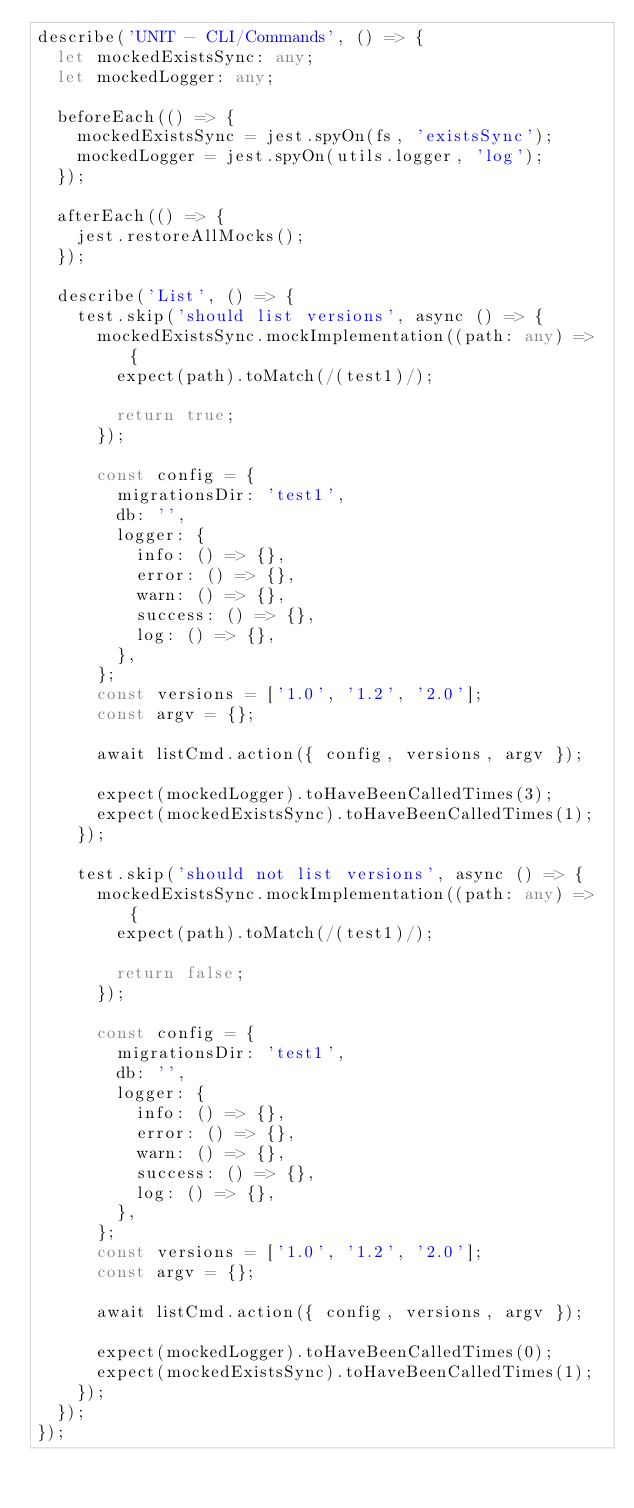<code> <loc_0><loc_0><loc_500><loc_500><_TypeScript_>describe('UNIT - CLI/Commands', () => {
  let mockedExistsSync: any;
  let mockedLogger: any;

  beforeEach(() => {
    mockedExistsSync = jest.spyOn(fs, 'existsSync');
    mockedLogger = jest.spyOn(utils.logger, 'log');
  });

  afterEach(() => {
    jest.restoreAllMocks();
  });

  describe('List', () => {
    test.skip('should list versions', async () => {
      mockedExistsSync.mockImplementation((path: any) => {
        expect(path).toMatch(/(test1)/);

        return true;
      });

      const config = {
        migrationsDir: 'test1',
        db: '',
        logger: {
          info: () => {},
          error: () => {},
          warn: () => {},
          success: () => {},
          log: () => {},
        },
      };
      const versions = ['1.0', '1.2', '2.0'];
      const argv = {};

      await listCmd.action({ config, versions, argv });

      expect(mockedLogger).toHaveBeenCalledTimes(3);
      expect(mockedExistsSync).toHaveBeenCalledTimes(1);
    });

    test.skip('should not list versions', async () => {
      mockedExistsSync.mockImplementation((path: any) => {
        expect(path).toMatch(/(test1)/);

        return false;
      });

      const config = {
        migrationsDir: 'test1',
        db: '',
        logger: {
          info: () => {},
          error: () => {},
          warn: () => {},
          success: () => {},
          log: () => {},
        },
      };
      const versions = ['1.0', '1.2', '2.0'];
      const argv = {};

      await listCmd.action({ config, versions, argv });

      expect(mockedLogger).toHaveBeenCalledTimes(0);
      expect(mockedExistsSync).toHaveBeenCalledTimes(1);
    });
  });
});
</code> 